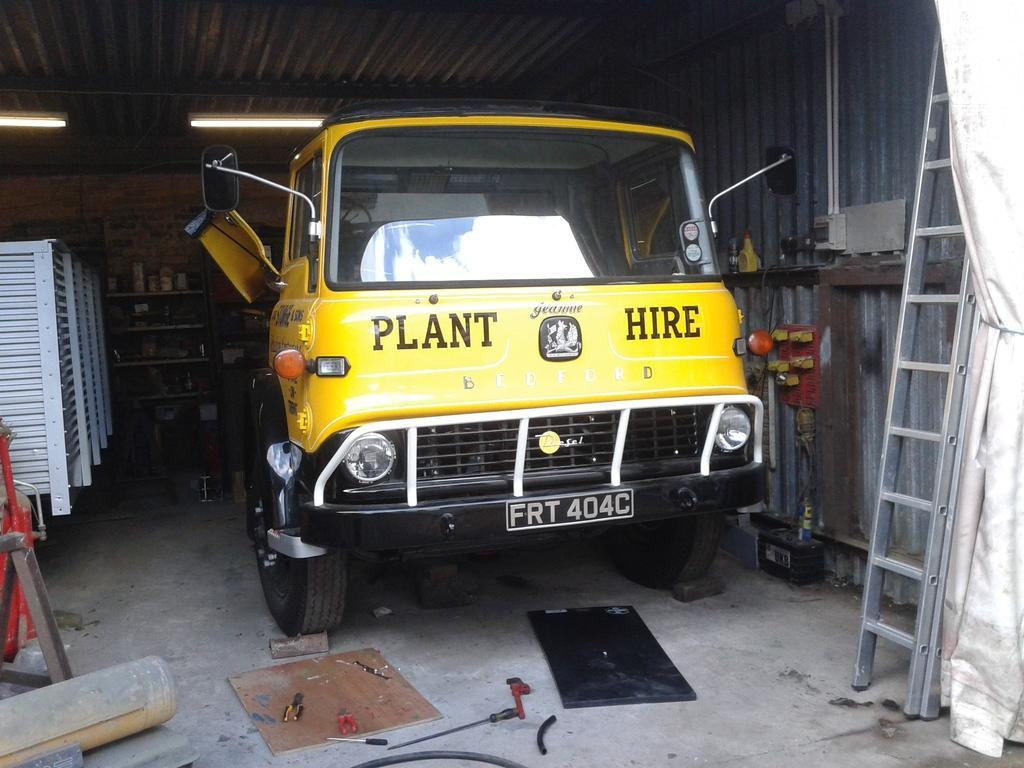Describe this image in one or two sentences. In this image we can see a shed. In the shed we can see a vehicle. In the background, we can see few objects on the shelves. On the left side, we can see few objects. On the right side there is a ladder and a curtain. At the bottom we can see few objects. 